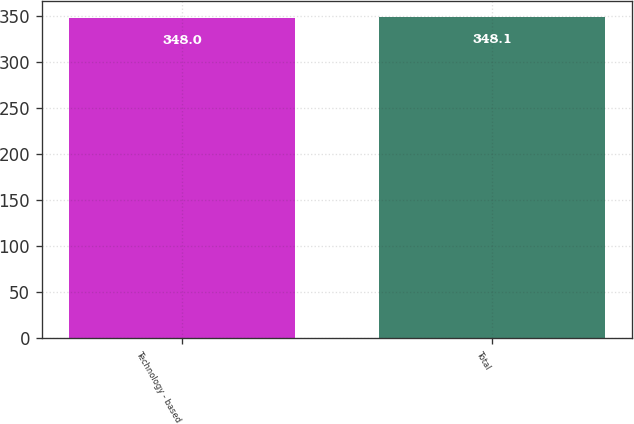<chart> <loc_0><loc_0><loc_500><loc_500><bar_chart><fcel>Technology - based<fcel>Total<nl><fcel>348<fcel>348.1<nl></chart> 